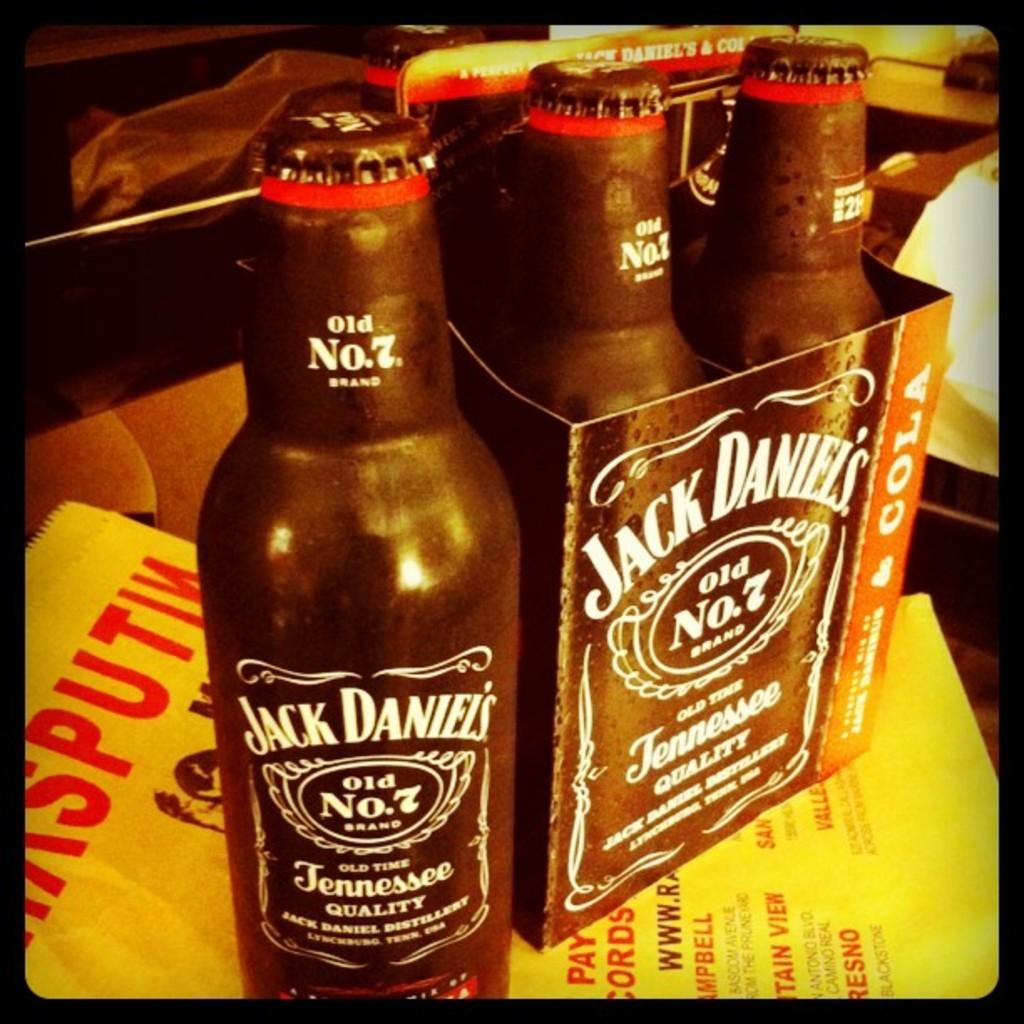What brand of alcohol is it?
Provide a succinct answer. Jack daniels. What kind of alcohol is shown?
Make the answer very short. Jack daniels. 